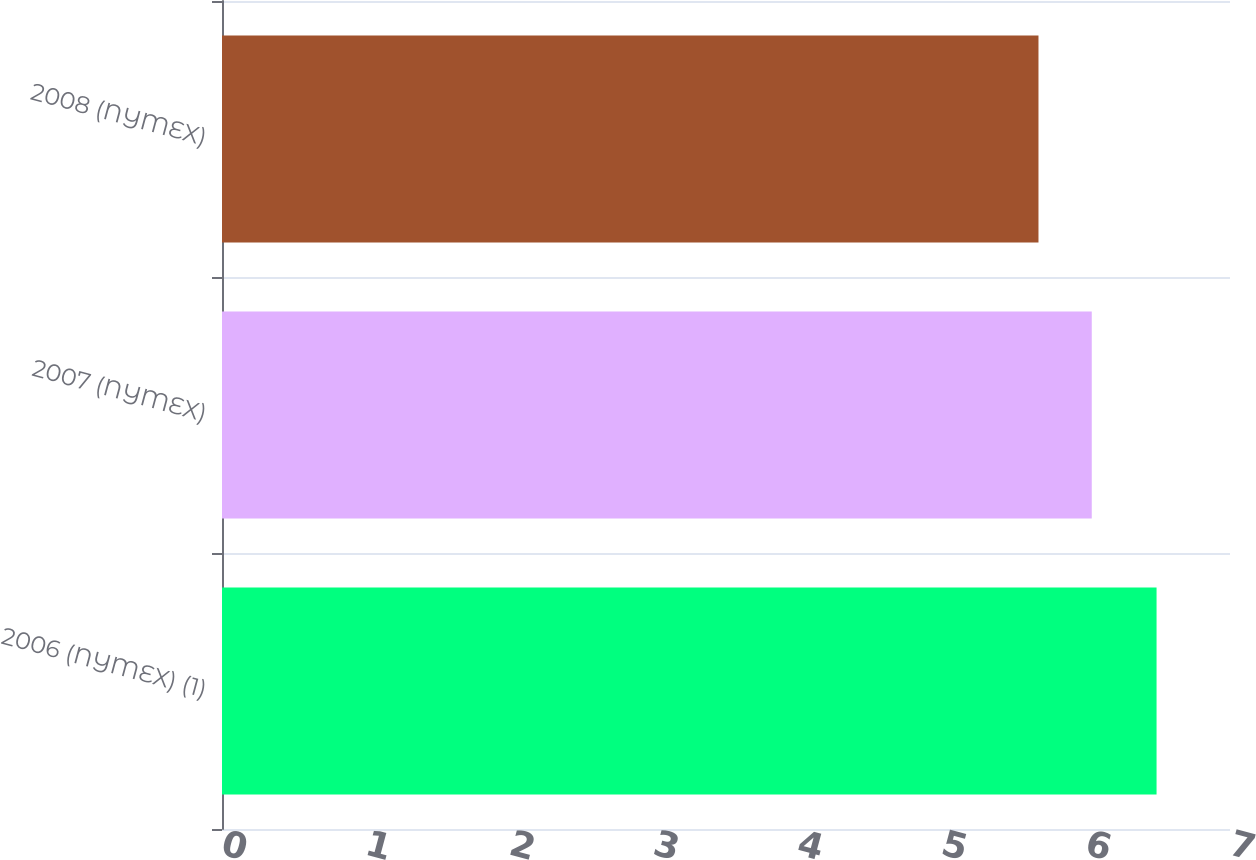Convert chart to OTSL. <chart><loc_0><loc_0><loc_500><loc_500><bar_chart><fcel>2006 (NYMEX) (1)<fcel>2007 (NYMEX)<fcel>2008 (NYMEX)<nl><fcel>6.49<fcel>6.04<fcel>5.67<nl></chart> 